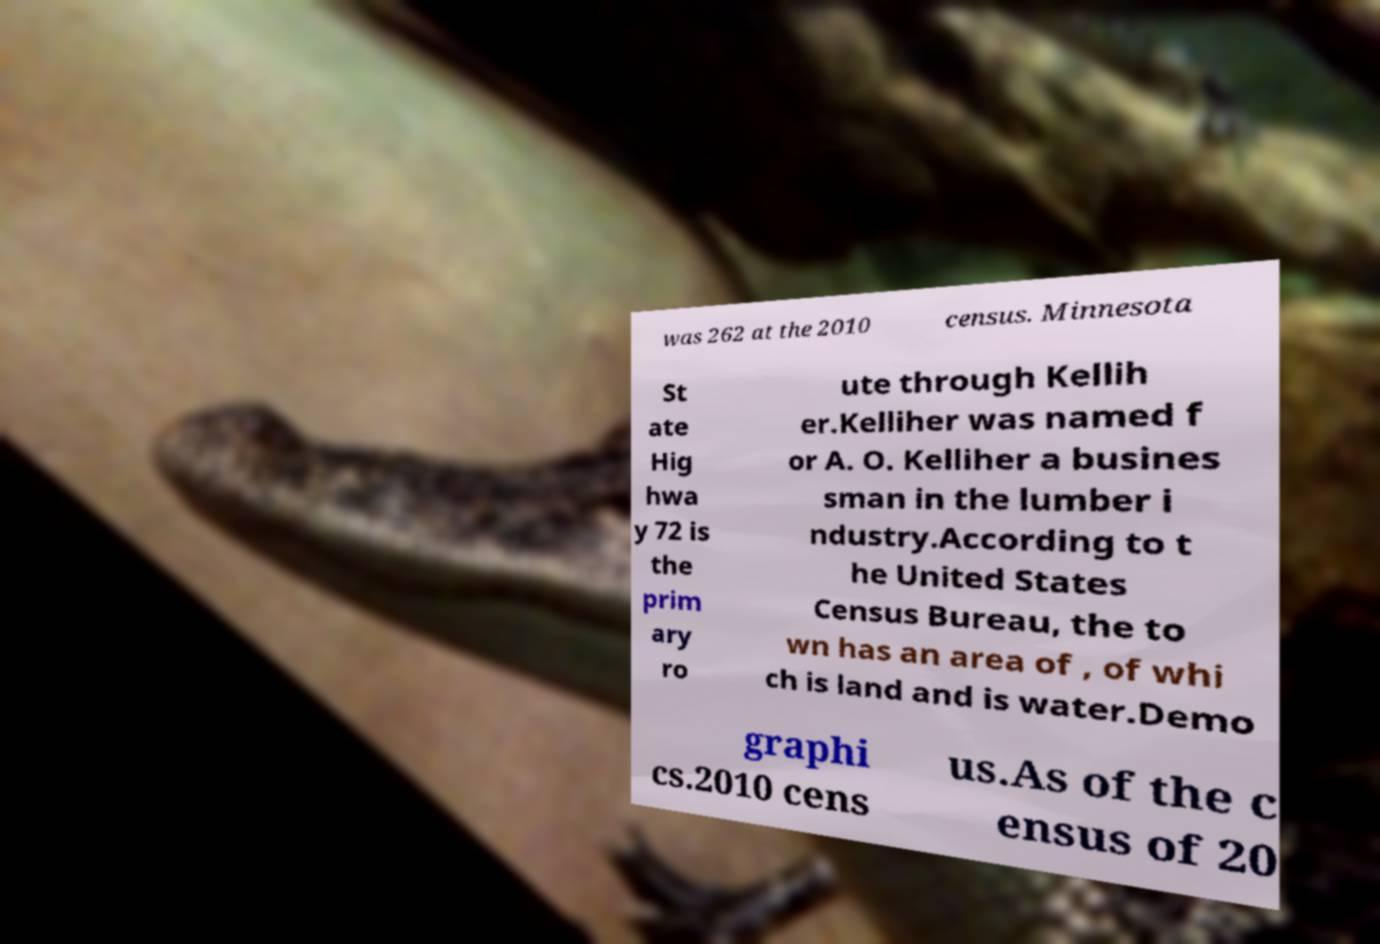Please identify and transcribe the text found in this image. was 262 at the 2010 census. Minnesota St ate Hig hwa y 72 is the prim ary ro ute through Kellih er.Kelliher was named f or A. O. Kelliher a busines sman in the lumber i ndustry.According to t he United States Census Bureau, the to wn has an area of , of whi ch is land and is water.Demo graphi cs.2010 cens us.As of the c ensus of 20 